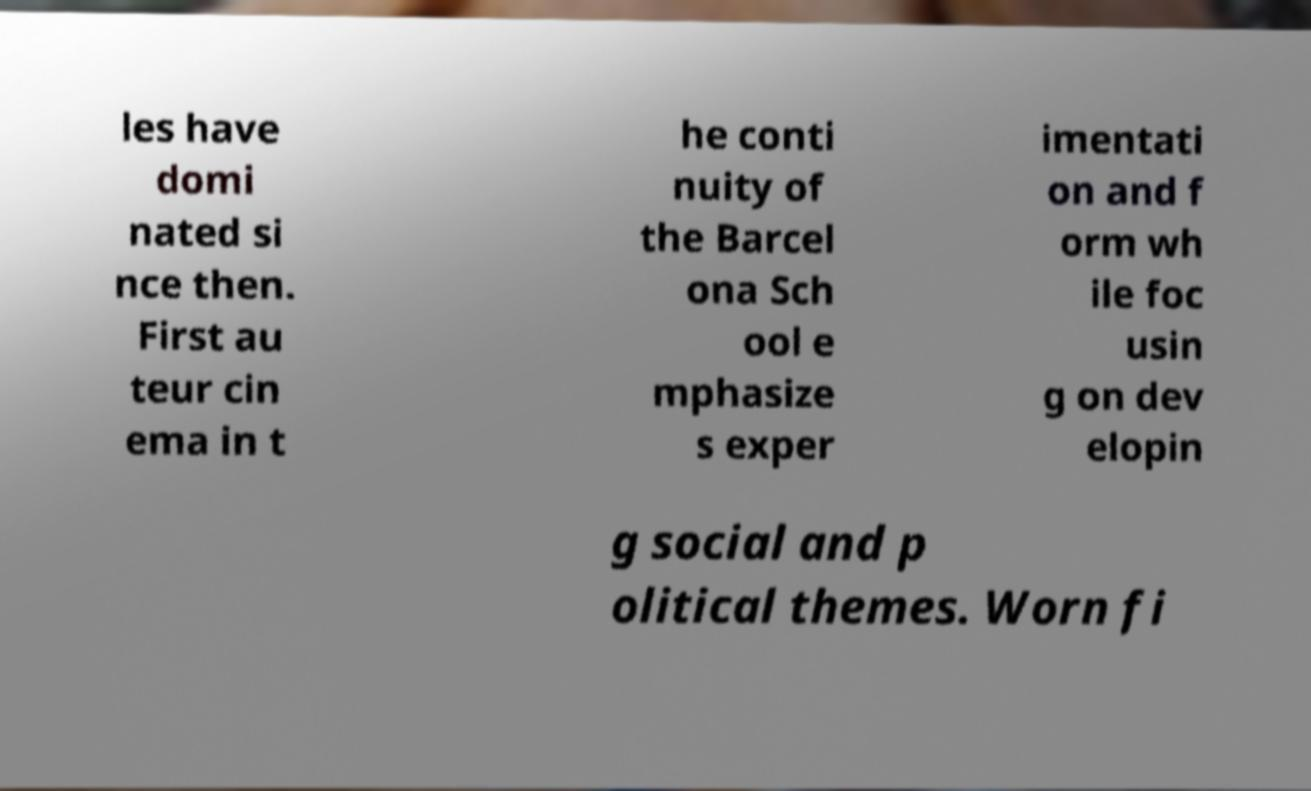Please read and relay the text visible in this image. What does it say? les have domi nated si nce then. First au teur cin ema in t he conti nuity of the Barcel ona Sch ool e mphasize s exper imentati on and f orm wh ile foc usin g on dev elopin g social and p olitical themes. Worn fi 